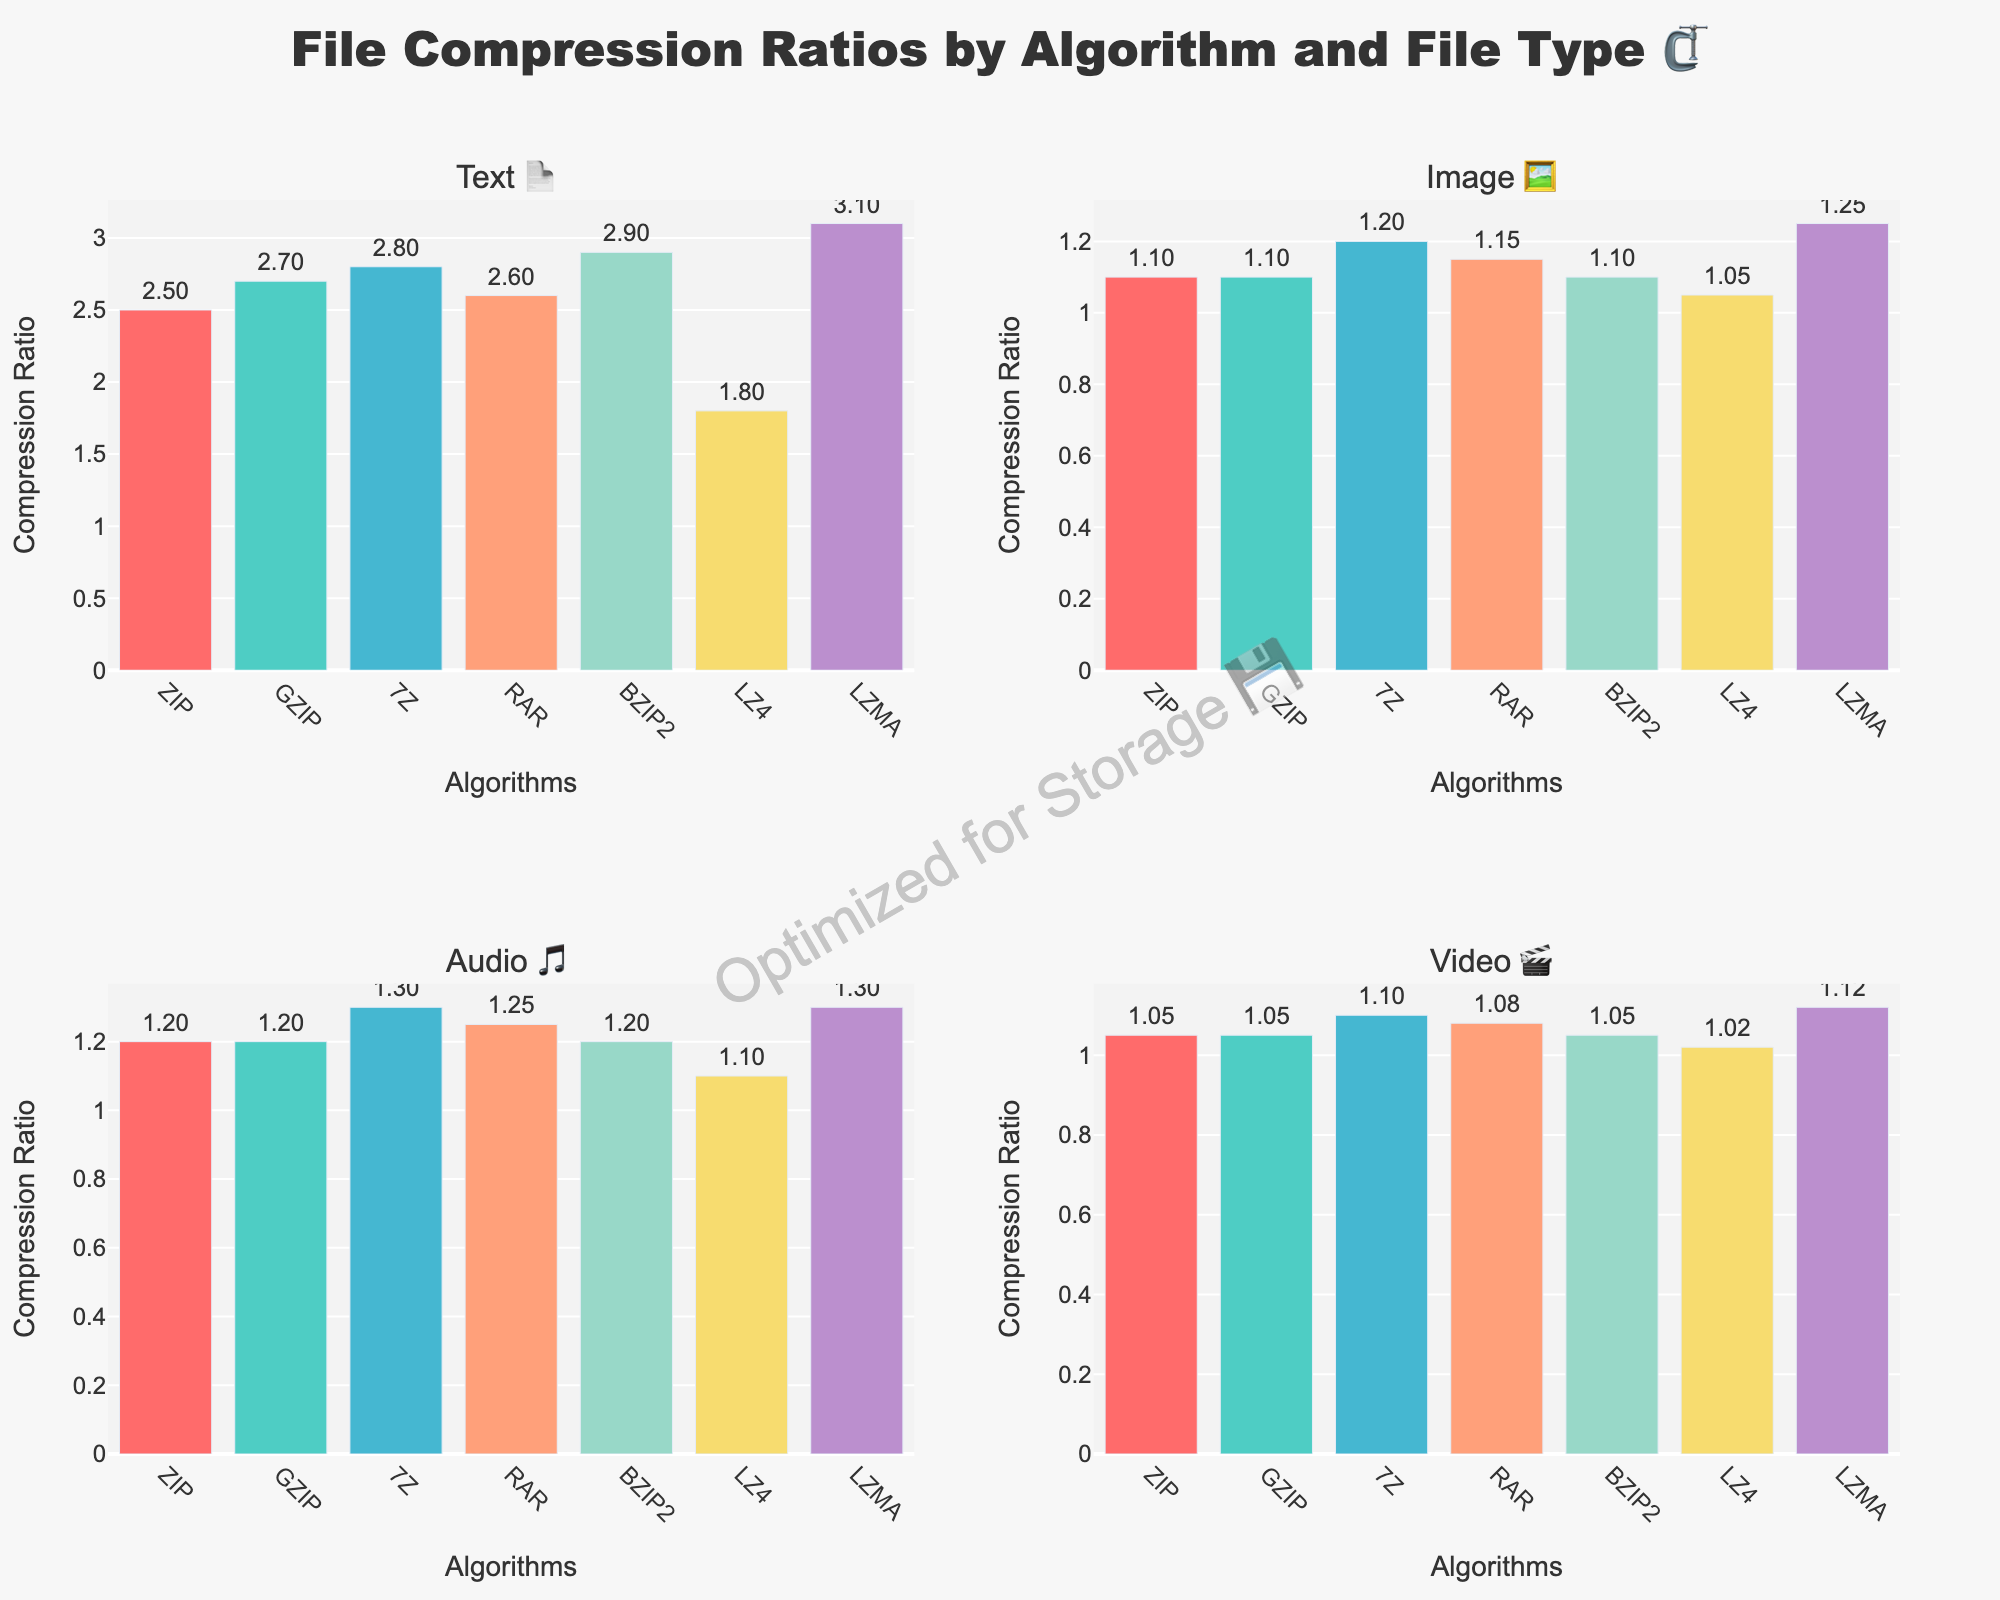What's the compression ratio of the LZMA algorithm for text files? Look at the bar representing the LZMA algorithm in the Text 📄 subplot. The height of the bar corresponds to the compression ratio.
Answer: 3.1 Which algorithm has the highest compression ratio for audio files 🎵? Compare all bars in the Audio 🎵 subplot and identify the tallest bar. The LZMA algorithm has the highest bar for audio files.
Answer: LZMA Is GZIP more effective than ZIP for compressing text files 📄? Look at the compression ratios for the GZIP and ZIP algorithms in the Text 📄 subplot. GZIP has a slightly higher ratio (2.7) than ZIP (2.5).
Answer: Yes What is the average compression ratio of the ZIP algorithm across all file types? The ZIP algorithm's ratios are 2.5 (Text), 1.1 (Image), 1.2 (Audio), and 1.05 (Video). Sum these values (2.5 + 1.1 + 1.2 + 1.05 = 5.85) and divide by 4.
Answer: 1.46 Which algorithm has the lowest compression ratio for video files 🎬? Look at the Video 🎬 subplot and identify the shortest bar. The LZ4 algorithm has the lowest compression ratio for video files (1.02).
Answer: LZ4 How much higher is the LZMA compression ratio for text files 📄 than the BZIP2 ratio for the same file type? LZMA has a ratio of 3.1 and BZIP2 has 2.9 for text files. Calculate the difference (3.1 - 2.9 = 0.2).
Answer: 0.2 Which file type is consistently compressed less effectively across all algorithms? Observe all subplots. Image 🖼️ files have the lowest compression ratios across all algorithms.
Answer: Image What are the compression ratios for the 7Z algorithm across all file types? Look at the bars for the 7Z algorithm in all subplots: Text (2.8), Image (1.2), Audio (1.3), and Video (1.1).
Answer: 2.8, 1.2, 1.3, 1.1 Is there any algorithm that performs equally well (same compression ratio) across multiple file types? Compare the bars for each algorithm across all subplots. Notice GZIP and BZIP2 have the same compression ratio for Image, Audio, and Video files (1.1, 1.2, 1.05).
Answer: Yes, GZIP and BZIP2 